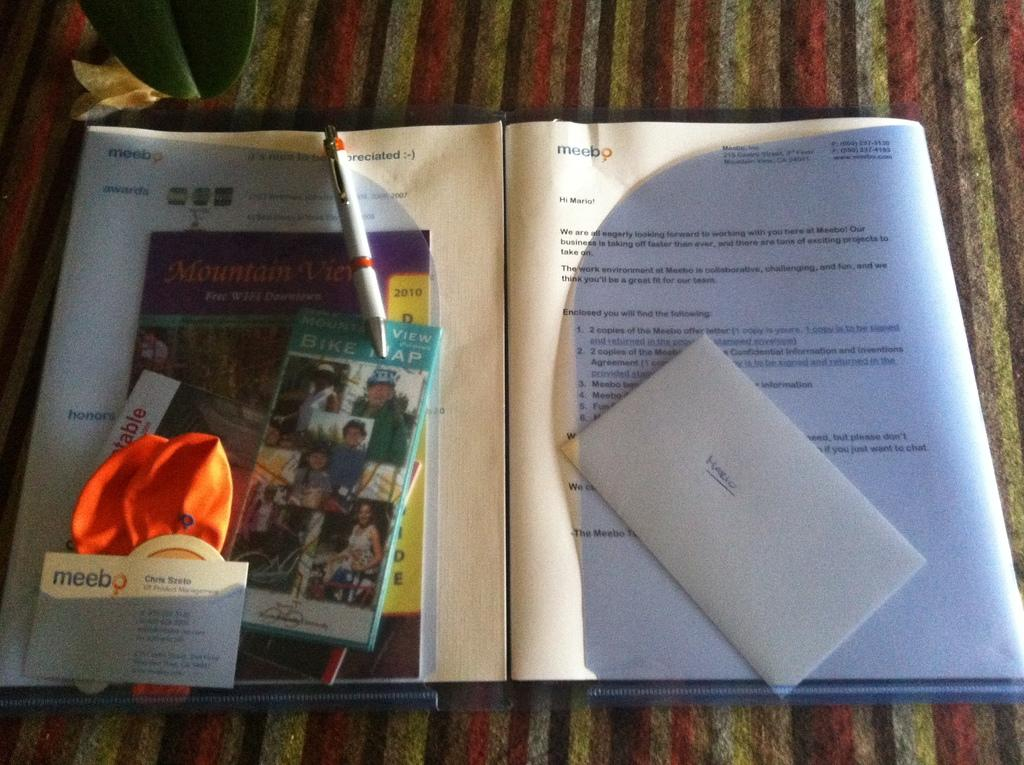<image>
Create a compact narrative representing the image presented. Open booklet that has a letter saying "Mario". 